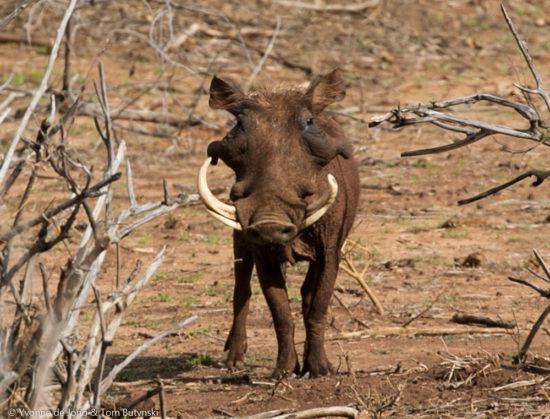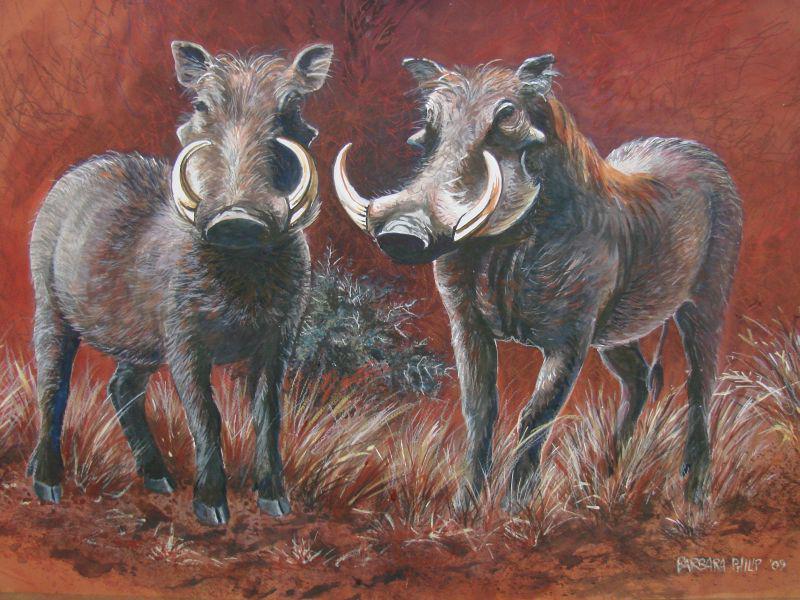The first image is the image on the left, the second image is the image on the right. Evaluate the accuracy of this statement regarding the images: "There is exactly two warthogs in the left image.". Is it true? Answer yes or no. No. The first image is the image on the left, the second image is the image on the right. Assess this claim about the two images: "The right image contains twice as many warthogs as the left image, and all warthogs are turned forward instead of in profile or backward.". Correct or not? Answer yes or no. Yes. 